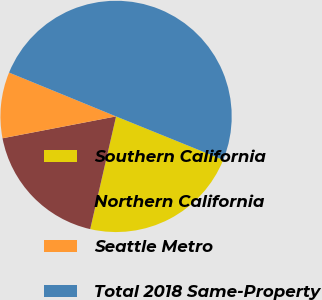<chart> <loc_0><loc_0><loc_500><loc_500><pie_chart><fcel>Southern California<fcel>Northern California<fcel>Seattle Metro<fcel>Total 2018 Same-Property<nl><fcel>22.46%<fcel>18.38%<fcel>9.22%<fcel>49.94%<nl></chart> 